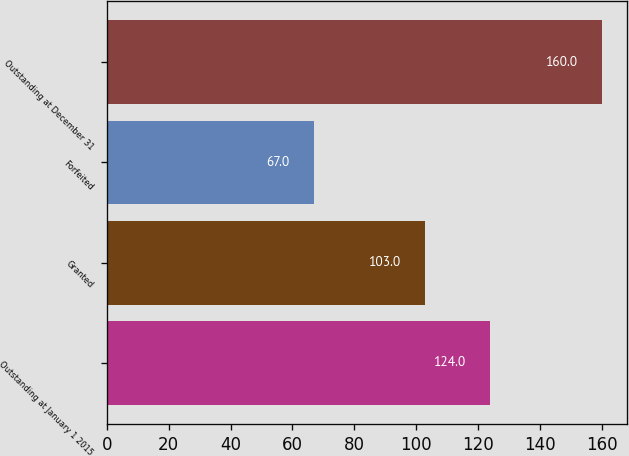<chart> <loc_0><loc_0><loc_500><loc_500><bar_chart><fcel>Outstanding at January 1 2015<fcel>Granted<fcel>Forfeited<fcel>Outstanding at December 31<nl><fcel>124<fcel>103<fcel>67<fcel>160<nl></chart> 